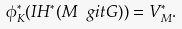<formula> <loc_0><loc_0><loc_500><loc_500>\phi ^ { * } _ { K } ( I H ^ { * } ( M \ g i t G ) ) = V _ { M } ^ { * } .</formula> 